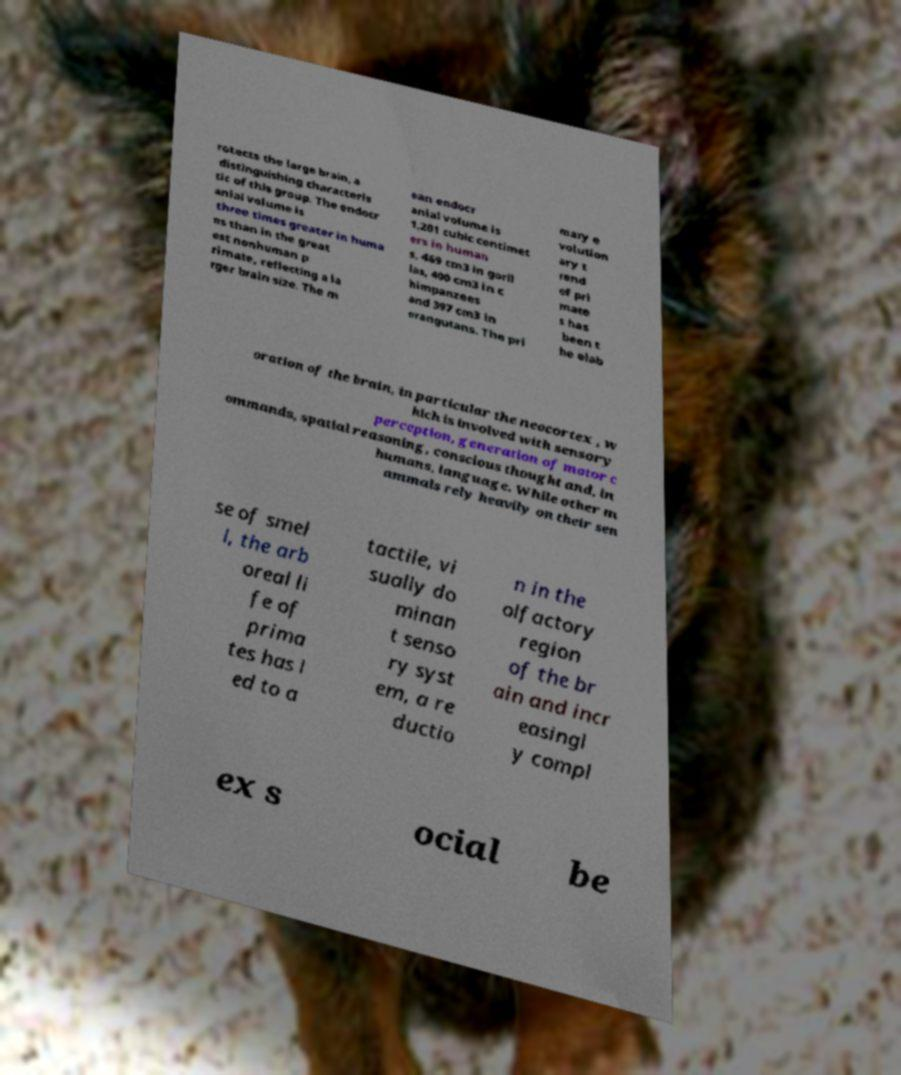Can you accurately transcribe the text from the provided image for me? rotects the large brain, a distinguishing characteris tic of this group. The endocr anial volume is three times greater in huma ns than in the great est nonhuman p rimate, reflecting a la rger brain size. The m ean endocr anial volume is 1,201 cubic centimet ers in human s, 469 cm3 in goril las, 400 cm3 in c himpanzees and 397 cm3 in orangutans. The pri mary e volution ary t rend of pri mate s has been t he elab oration of the brain, in particular the neocortex , w hich is involved with sensory perception, generation of motor c ommands, spatial reasoning, conscious thought and, in humans, language. While other m ammals rely heavily on their sen se of smel l, the arb oreal li fe of prima tes has l ed to a tactile, vi sually do minan t senso ry syst em, a re ductio n in the olfactory region of the br ain and incr easingl y compl ex s ocial be 